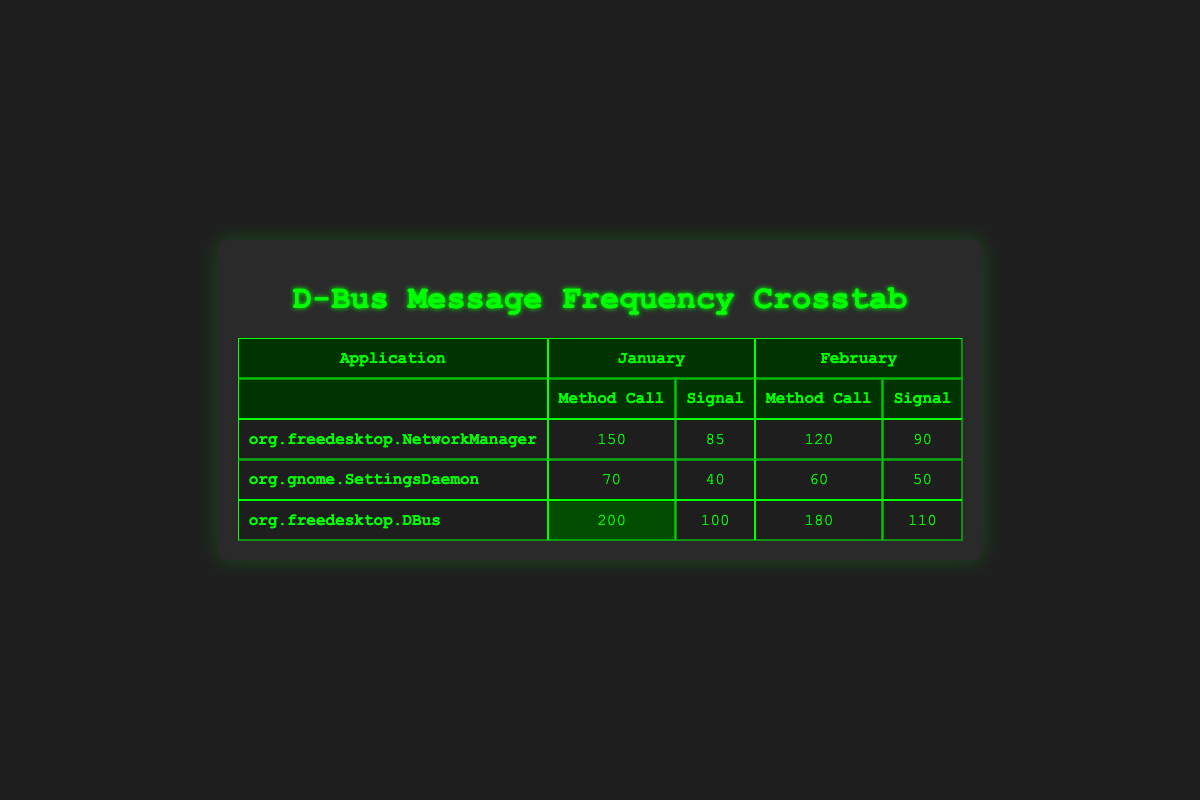What is the frequency of "Method Call" messages for the "org.freedesktop.NetworkManager" in January? In the table, I can find the row for "org.freedesktop.NetworkManager" under January. The frequency of the "Method Call" message type is listed as 150.
Answer: 150 What is the total frequency of "Signal" messages for "org.gnome.SettingsDaemon" across both January and February? To find the total frequency, I look for the "Signal" frequencies for "org.gnome.SettingsDaemon" in both months. In January, it is 40, and in February, it is 50. The total frequency is 40 + 50 = 90.
Answer: 90 Did the frequency of "Method Call" messages for "org.freedesktop.DBus" increase from January to February? In January, the frequency of "Method Call" messages for "org.freedesktop.DBus" is 200, and in February it is 180. Since 180 is less than 200, the frequency did not increase.
Answer: No What is the average frequency of "Signal" messages processed by all applications in February? I need to calculate the average of all "Signal" frequencies from February. The frequencies are 90 (NetworkManager), 50 (SettingsDaemon), and 110 (DBus). The sum is 90 + 50 + 110 = 250. Since there are 3 applications, the average is 250 / 3 ≈ 83.33.
Answer: Approximately 83.33 Which application had the highest frequency of "Method Call" messages in January? I can compare the frequencies for "Method Call" messages in January across all applications. "org.freedesktop.DBus" has a frequency of 200, whereas "org.freedesktop.NetworkManager" has 150, and "org.gnome.SettingsDaemon" has 70. The highest frequency is 200 for "org.freedesktop.DBus".
Answer: org.freedesktop.DBus What is the difference in "Signal" message frequency for "org.freedesktop.NetworkManager" between January and February? For "org.freedesktop.NetworkManager", the frequency of "Signal" messages is 85 in January and 90 in February. The difference is 90 - 85 = 5.
Answer: 5 How many total "Method Call" messages were processed between "org.freedesktop.NetworkManager" and "org.freedesktop.DBus" in February? I sum the "Method Call" frequencies for February for both applications. "org.freedesktop.NetworkManager" has a frequency of 120 and "org.freedesktop.DBus" has 180. Therefore, the total is 120 + 180 = 300.
Answer: 300 Is the frequency of "Signal" messages greater for "org.freedesktop.NetworkManager" than for "org.gnome.SettingsDaemon" in January? The frequency for "Signal" messages for "org.freedesktop.NetworkManager" is 85, while for "org.gnome.SettingsDaemon" it is 40 in January. Since 85 is greater than 40, the statement is true.
Answer: Yes 